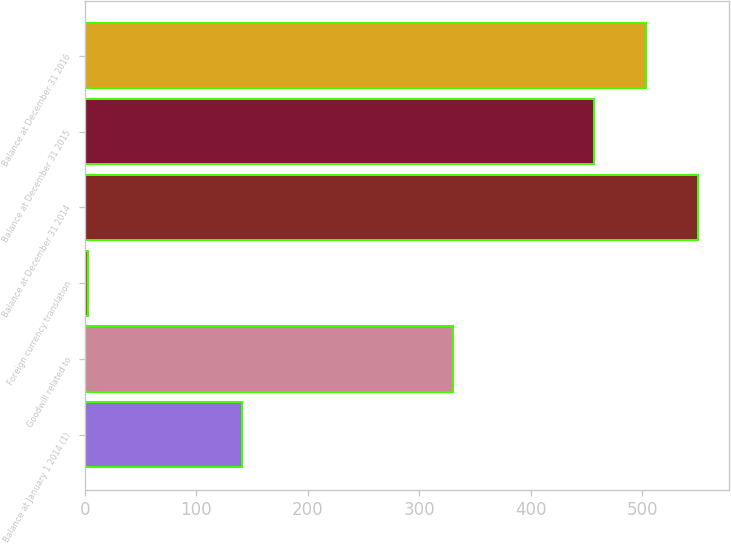Convert chart. <chart><loc_0><loc_0><loc_500><loc_500><bar_chart><fcel>Balance at January 1 2014 (1)<fcel>Goodwill related to<fcel>Foreign currency translation<fcel>Balance at December 31 2014<fcel>Balance at December 31 2015<fcel>Balance at December 31 2016<nl><fcel>141<fcel>330<fcel>3<fcel>550<fcel>457<fcel>503.5<nl></chart> 